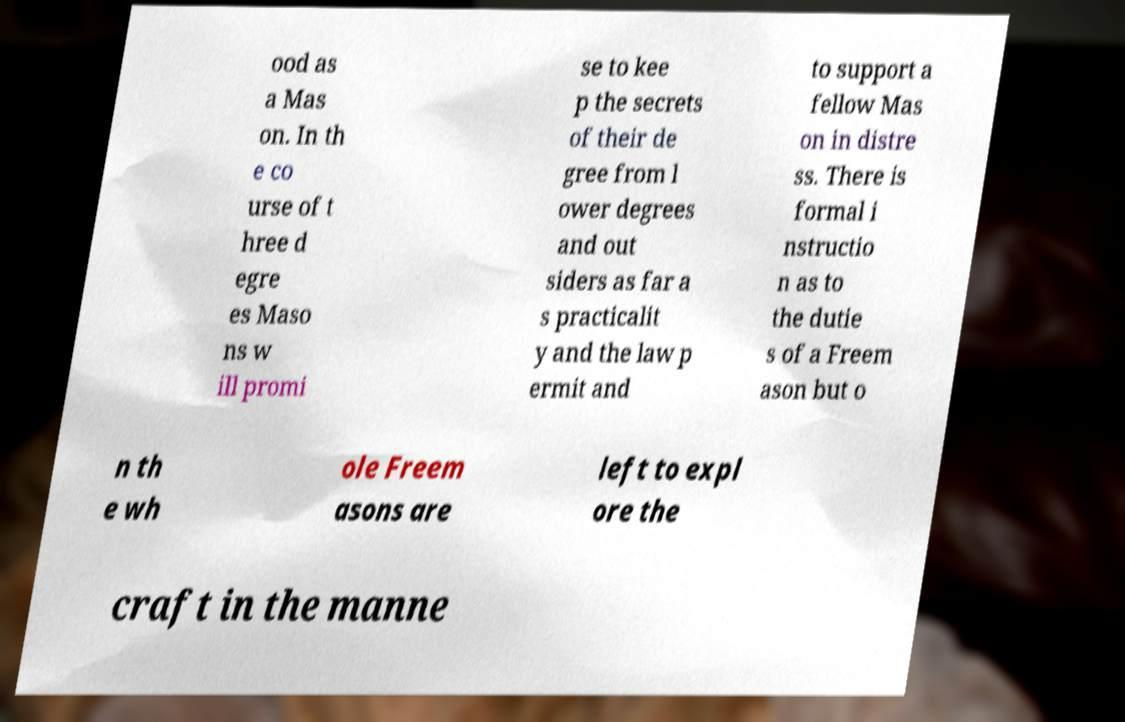I need the written content from this picture converted into text. Can you do that? ood as a Mas on. In th e co urse of t hree d egre es Maso ns w ill promi se to kee p the secrets of their de gree from l ower degrees and out siders as far a s practicalit y and the law p ermit and to support a fellow Mas on in distre ss. There is formal i nstructio n as to the dutie s of a Freem ason but o n th e wh ole Freem asons are left to expl ore the craft in the manne 